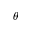Convert formula to latex. <formula><loc_0><loc_0><loc_500><loc_500>\theta</formula> 